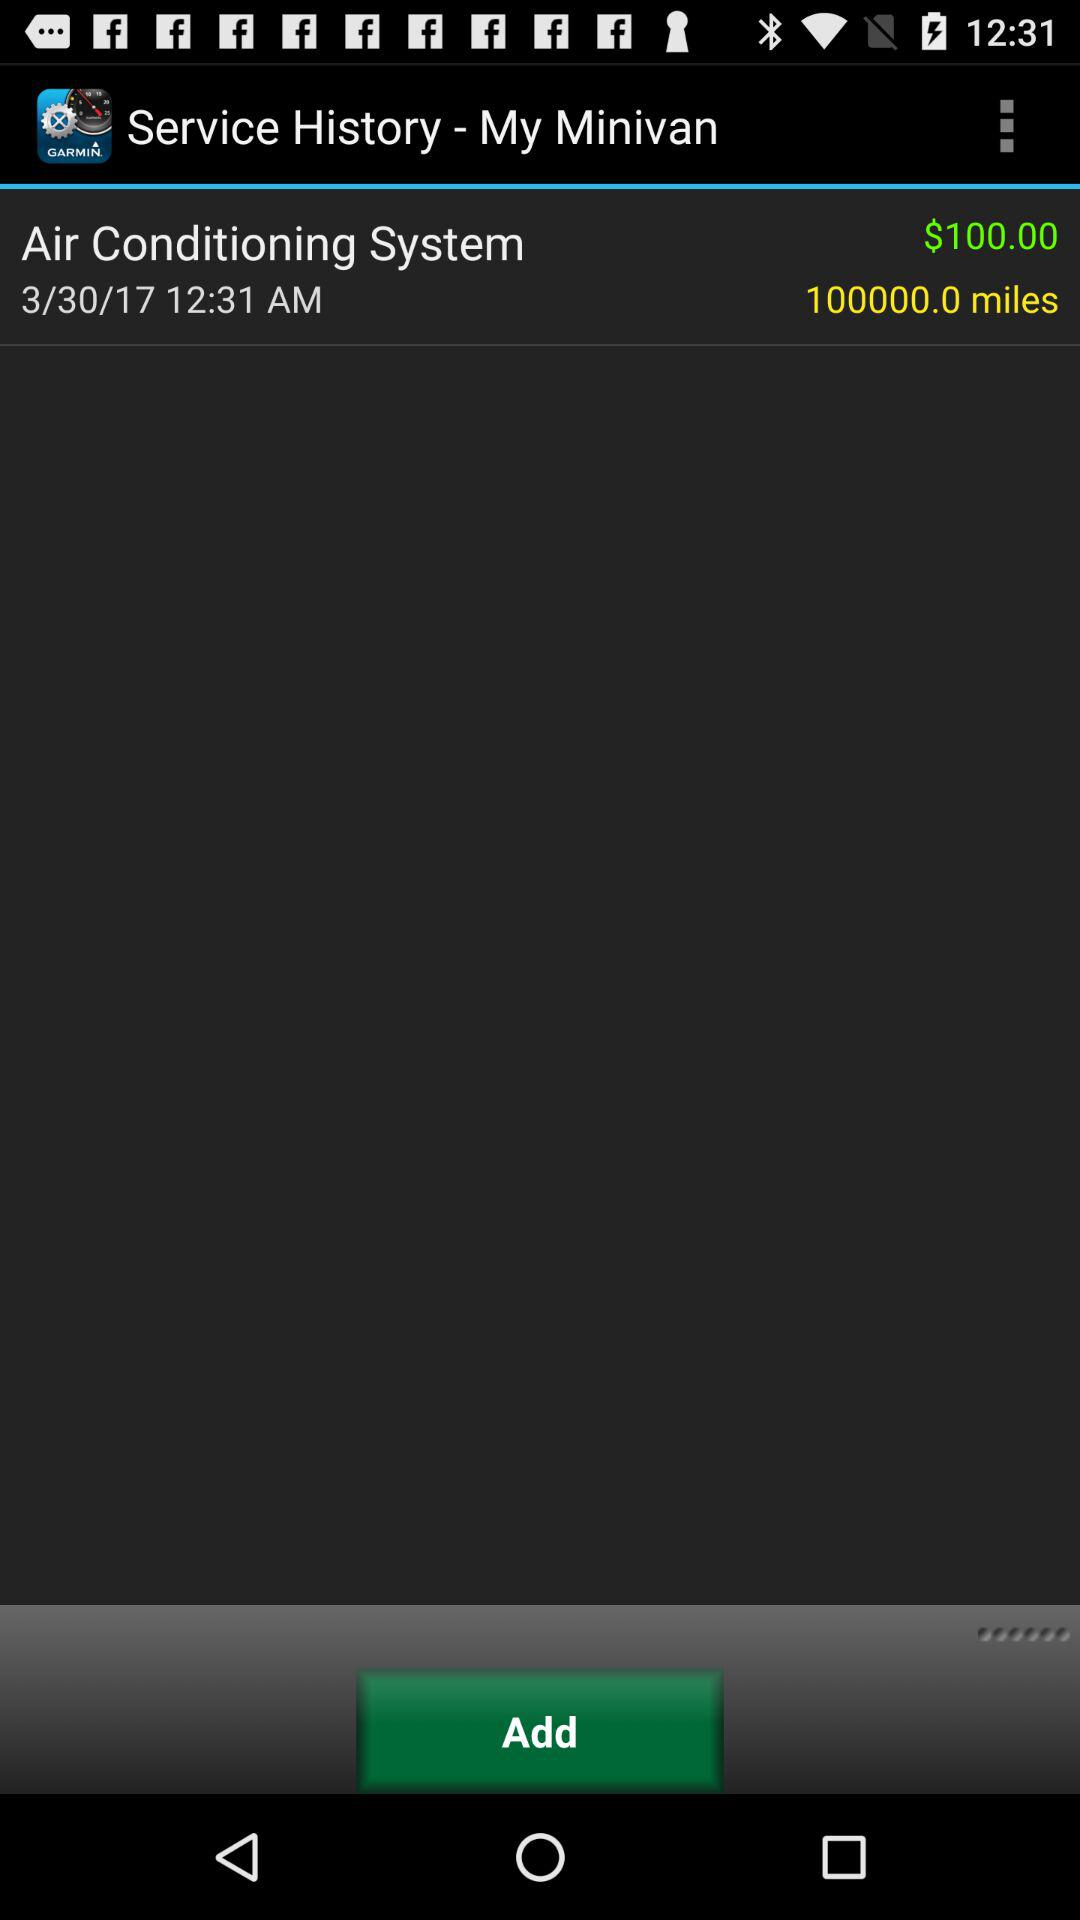What is the service time? The service time is 12:31 a.m. 